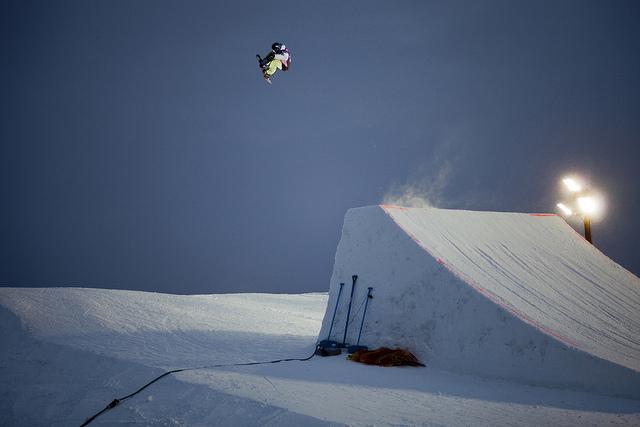What is the person doing?
Quick response, please. Snowboarding. Is it cold outside?
Give a very brief answer. Yes. How did the snowboarder end up in the air?
Give a very brief answer. Ramp. How high in the air is the person?
Write a very short answer. 20 feet. 